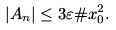Convert formula to latex. <formula><loc_0><loc_0><loc_500><loc_500>| A _ { n } | \leq 3 \varepsilon \# x _ { 0 } ^ { 2 } .</formula> 